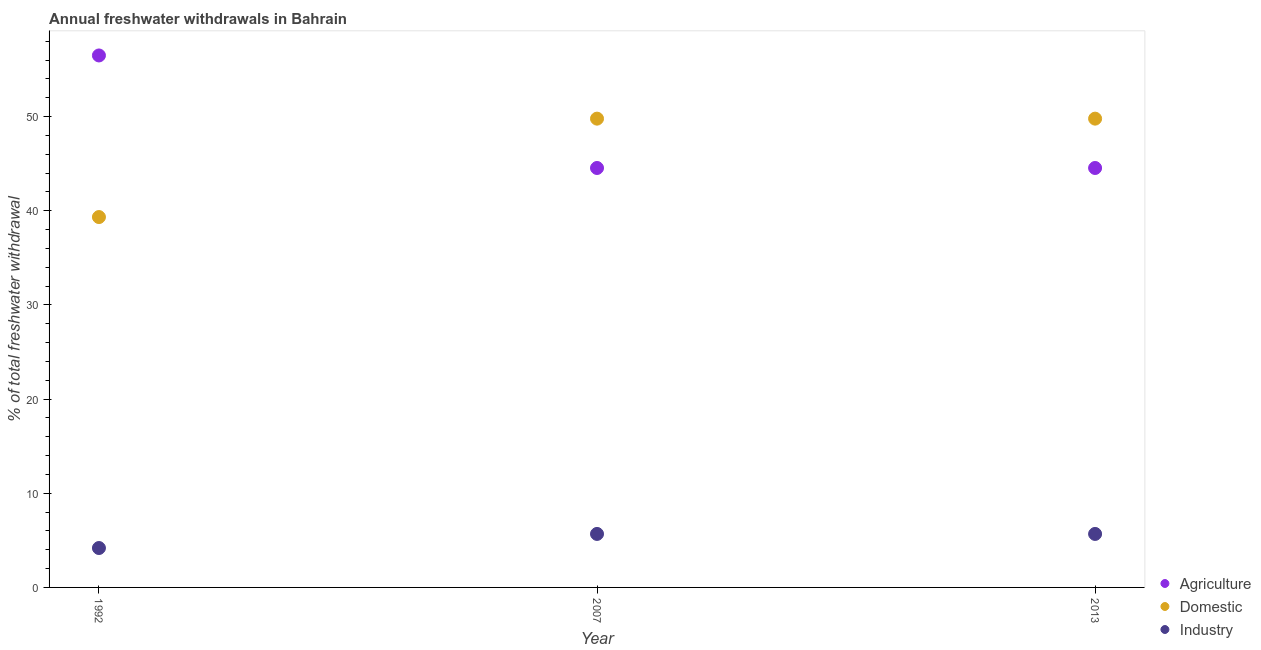How many different coloured dotlines are there?
Provide a succinct answer. 3. Is the number of dotlines equal to the number of legend labels?
Offer a terse response. Yes. What is the percentage of freshwater withdrawal for agriculture in 2013?
Provide a short and direct response. 44.54. Across all years, what is the maximum percentage of freshwater withdrawal for agriculture?
Provide a short and direct response. 56.49. Across all years, what is the minimum percentage of freshwater withdrawal for domestic purposes?
Make the answer very short. 39.33. What is the total percentage of freshwater withdrawal for agriculture in the graph?
Your response must be concise. 145.57. What is the difference between the percentage of freshwater withdrawal for industry in 2007 and that in 2013?
Offer a terse response. 0. What is the difference between the percentage of freshwater withdrawal for agriculture in 2007 and the percentage of freshwater withdrawal for industry in 1992?
Your answer should be compact. 40.36. What is the average percentage of freshwater withdrawal for industry per year?
Provide a short and direct response. 5.18. In the year 2013, what is the difference between the percentage of freshwater withdrawal for agriculture and percentage of freshwater withdrawal for domestic purposes?
Offer a terse response. -5.24. In how many years, is the percentage of freshwater withdrawal for domestic purposes greater than 2 %?
Offer a very short reply. 3. What is the ratio of the percentage of freshwater withdrawal for agriculture in 1992 to that in 2007?
Give a very brief answer. 1.27. Is the difference between the percentage of freshwater withdrawal for industry in 1992 and 2013 greater than the difference between the percentage of freshwater withdrawal for agriculture in 1992 and 2013?
Offer a terse response. No. What is the difference between the highest and the second highest percentage of freshwater withdrawal for domestic purposes?
Make the answer very short. 0. What is the difference between the highest and the lowest percentage of freshwater withdrawal for agriculture?
Ensure brevity in your answer.  11.95. In how many years, is the percentage of freshwater withdrawal for industry greater than the average percentage of freshwater withdrawal for industry taken over all years?
Give a very brief answer. 2. Is the sum of the percentage of freshwater withdrawal for domestic purposes in 2007 and 2013 greater than the maximum percentage of freshwater withdrawal for industry across all years?
Provide a short and direct response. Yes. Does the percentage of freshwater withdrawal for agriculture monotonically increase over the years?
Give a very brief answer. No. Is the percentage of freshwater withdrawal for domestic purposes strictly less than the percentage of freshwater withdrawal for agriculture over the years?
Provide a succinct answer. No. Are the values on the major ticks of Y-axis written in scientific E-notation?
Keep it short and to the point. No. Does the graph contain any zero values?
Offer a very short reply. No. Does the graph contain grids?
Offer a very short reply. No. Where does the legend appear in the graph?
Offer a very short reply. Bottom right. How many legend labels are there?
Provide a short and direct response. 3. How are the legend labels stacked?
Provide a succinct answer. Vertical. What is the title of the graph?
Offer a very short reply. Annual freshwater withdrawals in Bahrain. What is the label or title of the X-axis?
Give a very brief answer. Year. What is the label or title of the Y-axis?
Offer a very short reply. % of total freshwater withdrawal. What is the % of total freshwater withdrawal of Agriculture in 1992?
Ensure brevity in your answer.  56.49. What is the % of total freshwater withdrawal of Domestic in 1992?
Provide a short and direct response. 39.33. What is the % of total freshwater withdrawal in Industry in 1992?
Ensure brevity in your answer.  4.18. What is the % of total freshwater withdrawal in Agriculture in 2007?
Your response must be concise. 44.54. What is the % of total freshwater withdrawal of Domestic in 2007?
Your response must be concise. 49.78. What is the % of total freshwater withdrawal in Industry in 2007?
Your answer should be compact. 5.68. What is the % of total freshwater withdrawal in Agriculture in 2013?
Your response must be concise. 44.54. What is the % of total freshwater withdrawal in Domestic in 2013?
Give a very brief answer. 49.78. What is the % of total freshwater withdrawal in Industry in 2013?
Give a very brief answer. 5.68. Across all years, what is the maximum % of total freshwater withdrawal in Agriculture?
Your answer should be very brief. 56.49. Across all years, what is the maximum % of total freshwater withdrawal in Domestic?
Keep it short and to the point. 49.78. Across all years, what is the maximum % of total freshwater withdrawal of Industry?
Keep it short and to the point. 5.68. Across all years, what is the minimum % of total freshwater withdrawal of Agriculture?
Give a very brief answer. 44.54. Across all years, what is the minimum % of total freshwater withdrawal in Domestic?
Provide a succinct answer. 39.33. Across all years, what is the minimum % of total freshwater withdrawal of Industry?
Make the answer very short. 4.18. What is the total % of total freshwater withdrawal of Agriculture in the graph?
Provide a short and direct response. 145.57. What is the total % of total freshwater withdrawal of Domestic in the graph?
Provide a short and direct response. 138.89. What is the total % of total freshwater withdrawal of Industry in the graph?
Make the answer very short. 15.54. What is the difference between the % of total freshwater withdrawal of Agriculture in 1992 and that in 2007?
Keep it short and to the point. 11.95. What is the difference between the % of total freshwater withdrawal in Domestic in 1992 and that in 2007?
Keep it short and to the point. -10.45. What is the difference between the % of total freshwater withdrawal of Industry in 1992 and that in 2007?
Your answer should be very brief. -1.5. What is the difference between the % of total freshwater withdrawal in Agriculture in 1992 and that in 2013?
Ensure brevity in your answer.  11.95. What is the difference between the % of total freshwater withdrawal of Domestic in 1992 and that in 2013?
Ensure brevity in your answer.  -10.45. What is the difference between the % of total freshwater withdrawal in Industry in 1992 and that in 2013?
Your response must be concise. -1.5. What is the difference between the % of total freshwater withdrawal in Domestic in 2007 and that in 2013?
Your answer should be very brief. 0. What is the difference between the % of total freshwater withdrawal in Agriculture in 1992 and the % of total freshwater withdrawal in Domestic in 2007?
Offer a terse response. 6.71. What is the difference between the % of total freshwater withdrawal in Agriculture in 1992 and the % of total freshwater withdrawal in Industry in 2007?
Your response must be concise. 50.81. What is the difference between the % of total freshwater withdrawal of Domestic in 1992 and the % of total freshwater withdrawal of Industry in 2007?
Ensure brevity in your answer.  33.65. What is the difference between the % of total freshwater withdrawal in Agriculture in 1992 and the % of total freshwater withdrawal in Domestic in 2013?
Provide a short and direct response. 6.71. What is the difference between the % of total freshwater withdrawal of Agriculture in 1992 and the % of total freshwater withdrawal of Industry in 2013?
Your answer should be compact. 50.81. What is the difference between the % of total freshwater withdrawal of Domestic in 1992 and the % of total freshwater withdrawal of Industry in 2013?
Keep it short and to the point. 33.65. What is the difference between the % of total freshwater withdrawal in Agriculture in 2007 and the % of total freshwater withdrawal in Domestic in 2013?
Ensure brevity in your answer.  -5.24. What is the difference between the % of total freshwater withdrawal of Agriculture in 2007 and the % of total freshwater withdrawal of Industry in 2013?
Ensure brevity in your answer.  38.86. What is the difference between the % of total freshwater withdrawal in Domestic in 2007 and the % of total freshwater withdrawal in Industry in 2013?
Your response must be concise. 44.1. What is the average % of total freshwater withdrawal in Agriculture per year?
Your answer should be compact. 48.52. What is the average % of total freshwater withdrawal of Domestic per year?
Your answer should be very brief. 46.3. What is the average % of total freshwater withdrawal in Industry per year?
Make the answer very short. 5.18. In the year 1992, what is the difference between the % of total freshwater withdrawal of Agriculture and % of total freshwater withdrawal of Domestic?
Your answer should be compact. 17.16. In the year 1992, what is the difference between the % of total freshwater withdrawal of Agriculture and % of total freshwater withdrawal of Industry?
Give a very brief answer. 52.31. In the year 1992, what is the difference between the % of total freshwater withdrawal of Domestic and % of total freshwater withdrawal of Industry?
Provide a short and direct response. 35.15. In the year 2007, what is the difference between the % of total freshwater withdrawal of Agriculture and % of total freshwater withdrawal of Domestic?
Your response must be concise. -5.24. In the year 2007, what is the difference between the % of total freshwater withdrawal in Agriculture and % of total freshwater withdrawal in Industry?
Your answer should be compact. 38.86. In the year 2007, what is the difference between the % of total freshwater withdrawal of Domestic and % of total freshwater withdrawal of Industry?
Keep it short and to the point. 44.1. In the year 2013, what is the difference between the % of total freshwater withdrawal of Agriculture and % of total freshwater withdrawal of Domestic?
Ensure brevity in your answer.  -5.24. In the year 2013, what is the difference between the % of total freshwater withdrawal in Agriculture and % of total freshwater withdrawal in Industry?
Your answer should be compact. 38.86. In the year 2013, what is the difference between the % of total freshwater withdrawal in Domestic and % of total freshwater withdrawal in Industry?
Offer a very short reply. 44.1. What is the ratio of the % of total freshwater withdrawal in Agriculture in 1992 to that in 2007?
Offer a terse response. 1.27. What is the ratio of the % of total freshwater withdrawal of Domestic in 1992 to that in 2007?
Make the answer very short. 0.79. What is the ratio of the % of total freshwater withdrawal of Industry in 1992 to that in 2007?
Keep it short and to the point. 0.74. What is the ratio of the % of total freshwater withdrawal of Agriculture in 1992 to that in 2013?
Offer a terse response. 1.27. What is the ratio of the % of total freshwater withdrawal of Domestic in 1992 to that in 2013?
Provide a short and direct response. 0.79. What is the ratio of the % of total freshwater withdrawal in Industry in 1992 to that in 2013?
Give a very brief answer. 0.74. What is the ratio of the % of total freshwater withdrawal of Agriculture in 2007 to that in 2013?
Your response must be concise. 1. What is the ratio of the % of total freshwater withdrawal of Industry in 2007 to that in 2013?
Your answer should be compact. 1. What is the difference between the highest and the second highest % of total freshwater withdrawal of Agriculture?
Your response must be concise. 11.95. What is the difference between the highest and the second highest % of total freshwater withdrawal of Industry?
Give a very brief answer. 0. What is the difference between the highest and the lowest % of total freshwater withdrawal in Agriculture?
Offer a very short reply. 11.95. What is the difference between the highest and the lowest % of total freshwater withdrawal of Domestic?
Give a very brief answer. 10.45. What is the difference between the highest and the lowest % of total freshwater withdrawal of Industry?
Your answer should be compact. 1.5. 